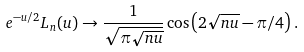Convert formula to latex. <formula><loc_0><loc_0><loc_500><loc_500>\ e ^ { - u / 2 } L _ { n } ( u ) \to \frac { 1 } { \sqrt { \pi \sqrt { n u } } } \cos \left ( 2 \sqrt { n u } - \pi / 4 \right ) .</formula> 